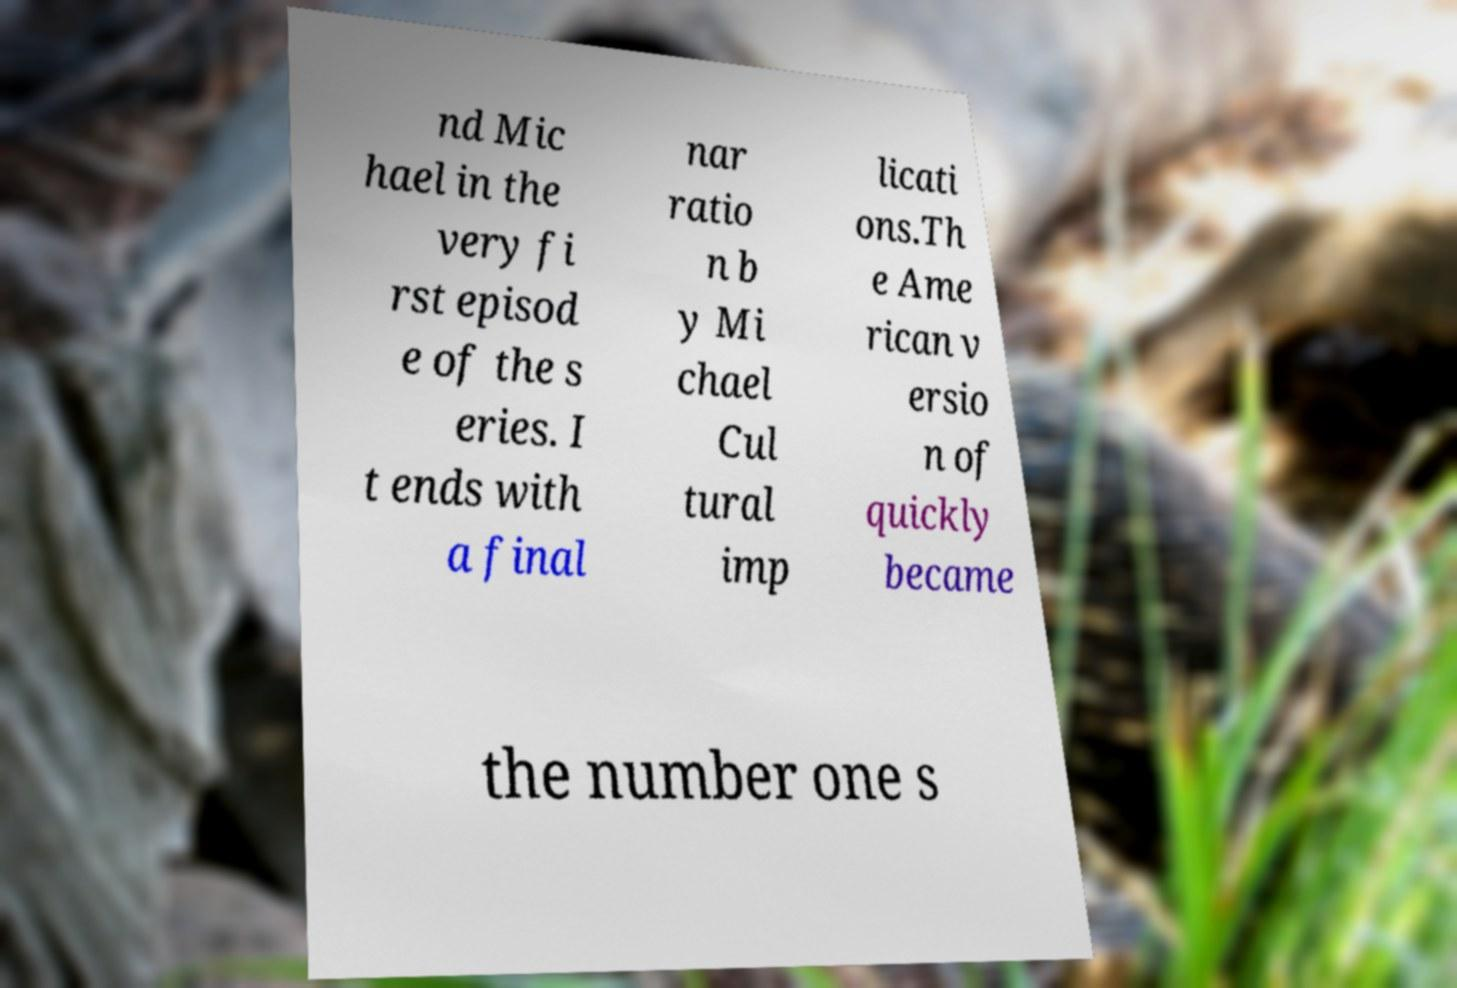For documentation purposes, I need the text within this image transcribed. Could you provide that? nd Mic hael in the very fi rst episod e of the s eries. I t ends with a final nar ratio n b y Mi chael Cul tural imp licati ons.Th e Ame rican v ersio n of quickly became the number one s 